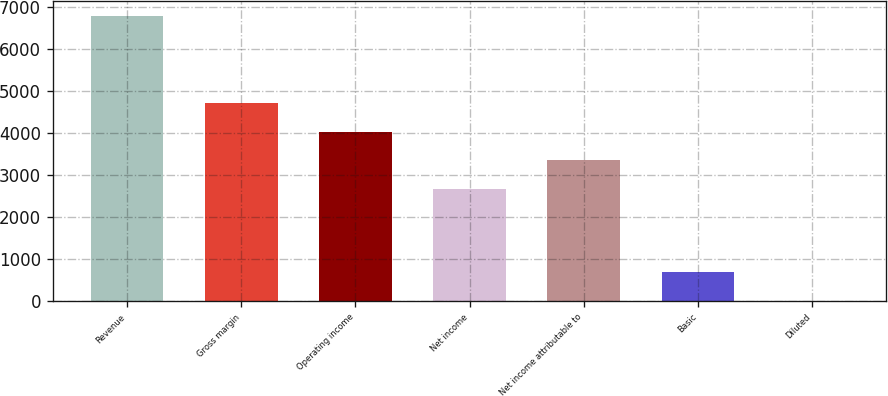<chart> <loc_0><loc_0><loc_500><loc_500><bar_chart><fcel>Revenue<fcel>Gross margin<fcel>Operating income<fcel>Net income<fcel>Net income attributable to<fcel>Basic<fcel>Diluted<nl><fcel>6803<fcel>4718.24<fcel>4038.16<fcel>2678<fcel>3358.08<fcel>682.27<fcel>2.19<nl></chart> 